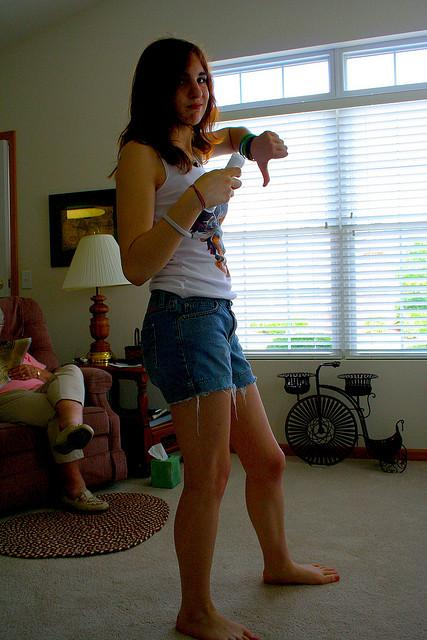What is the window covering called? Please explain your reasoning. blinds. There are horizontal lines across the window that can be adjusted. 